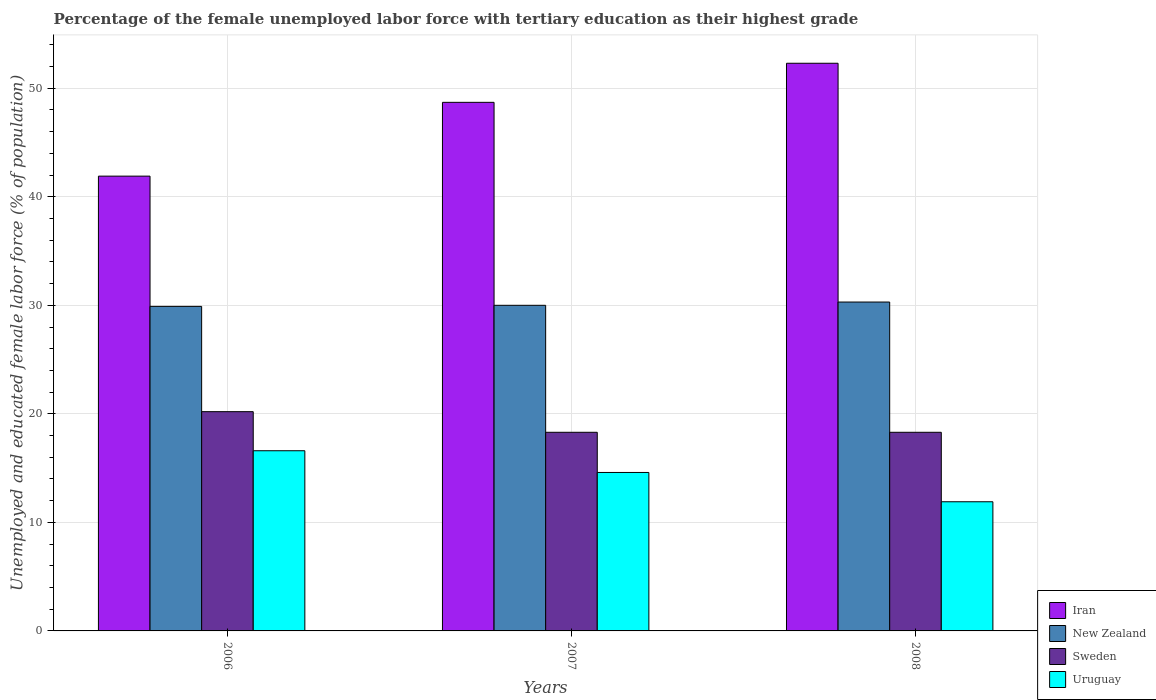How many different coloured bars are there?
Give a very brief answer. 4. How many bars are there on the 2nd tick from the right?
Ensure brevity in your answer.  4. What is the label of the 3rd group of bars from the left?
Your response must be concise. 2008. In how many cases, is the number of bars for a given year not equal to the number of legend labels?
Ensure brevity in your answer.  0. What is the percentage of the unemployed female labor force with tertiary education in New Zealand in 2008?
Give a very brief answer. 30.3. Across all years, what is the maximum percentage of the unemployed female labor force with tertiary education in Uruguay?
Keep it short and to the point. 16.6. Across all years, what is the minimum percentage of the unemployed female labor force with tertiary education in Iran?
Provide a succinct answer. 41.9. What is the total percentage of the unemployed female labor force with tertiary education in Uruguay in the graph?
Your answer should be very brief. 43.1. What is the difference between the percentage of the unemployed female labor force with tertiary education in Uruguay in 2007 and the percentage of the unemployed female labor force with tertiary education in Sweden in 2006?
Provide a succinct answer. -5.6. What is the average percentage of the unemployed female labor force with tertiary education in New Zealand per year?
Your response must be concise. 30.07. In the year 2008, what is the difference between the percentage of the unemployed female labor force with tertiary education in Sweden and percentage of the unemployed female labor force with tertiary education in Iran?
Your response must be concise. -34. In how many years, is the percentage of the unemployed female labor force with tertiary education in Uruguay greater than 52 %?
Keep it short and to the point. 0. What is the ratio of the percentage of the unemployed female labor force with tertiary education in Uruguay in 2006 to that in 2007?
Your answer should be compact. 1.14. Is the percentage of the unemployed female labor force with tertiary education in Sweden in 2006 less than that in 2007?
Give a very brief answer. No. What is the difference between the highest and the second highest percentage of the unemployed female labor force with tertiary education in New Zealand?
Offer a very short reply. 0.3. What is the difference between the highest and the lowest percentage of the unemployed female labor force with tertiary education in Iran?
Offer a very short reply. 10.4. Is the sum of the percentage of the unemployed female labor force with tertiary education in New Zealand in 2007 and 2008 greater than the maximum percentage of the unemployed female labor force with tertiary education in Sweden across all years?
Give a very brief answer. Yes. Is it the case that in every year, the sum of the percentage of the unemployed female labor force with tertiary education in Iran and percentage of the unemployed female labor force with tertiary education in Sweden is greater than the sum of percentage of the unemployed female labor force with tertiary education in Uruguay and percentage of the unemployed female labor force with tertiary education in New Zealand?
Give a very brief answer. No. What does the 1st bar from the left in 2006 represents?
Provide a short and direct response. Iran. What does the 3rd bar from the right in 2006 represents?
Give a very brief answer. New Zealand. Is it the case that in every year, the sum of the percentage of the unemployed female labor force with tertiary education in Sweden and percentage of the unemployed female labor force with tertiary education in Iran is greater than the percentage of the unemployed female labor force with tertiary education in Uruguay?
Your answer should be very brief. Yes. How many bars are there?
Your answer should be compact. 12. How many years are there in the graph?
Give a very brief answer. 3. What is the difference between two consecutive major ticks on the Y-axis?
Your response must be concise. 10. Where does the legend appear in the graph?
Offer a terse response. Bottom right. How many legend labels are there?
Offer a terse response. 4. How are the legend labels stacked?
Provide a short and direct response. Vertical. What is the title of the graph?
Your answer should be compact. Percentage of the female unemployed labor force with tertiary education as their highest grade. Does "Estonia" appear as one of the legend labels in the graph?
Offer a terse response. No. What is the label or title of the Y-axis?
Offer a very short reply. Unemployed and educated female labor force (% of population). What is the Unemployed and educated female labor force (% of population) of Iran in 2006?
Keep it short and to the point. 41.9. What is the Unemployed and educated female labor force (% of population) of New Zealand in 2006?
Your response must be concise. 29.9. What is the Unemployed and educated female labor force (% of population) in Sweden in 2006?
Your answer should be compact. 20.2. What is the Unemployed and educated female labor force (% of population) of Uruguay in 2006?
Make the answer very short. 16.6. What is the Unemployed and educated female labor force (% of population) in Iran in 2007?
Ensure brevity in your answer.  48.7. What is the Unemployed and educated female labor force (% of population) in New Zealand in 2007?
Make the answer very short. 30. What is the Unemployed and educated female labor force (% of population) of Sweden in 2007?
Keep it short and to the point. 18.3. What is the Unemployed and educated female labor force (% of population) of Uruguay in 2007?
Offer a very short reply. 14.6. What is the Unemployed and educated female labor force (% of population) in Iran in 2008?
Provide a short and direct response. 52.3. What is the Unemployed and educated female labor force (% of population) in New Zealand in 2008?
Make the answer very short. 30.3. What is the Unemployed and educated female labor force (% of population) of Sweden in 2008?
Offer a terse response. 18.3. What is the Unemployed and educated female labor force (% of population) of Uruguay in 2008?
Ensure brevity in your answer.  11.9. Across all years, what is the maximum Unemployed and educated female labor force (% of population) of Iran?
Offer a terse response. 52.3. Across all years, what is the maximum Unemployed and educated female labor force (% of population) in New Zealand?
Offer a terse response. 30.3. Across all years, what is the maximum Unemployed and educated female labor force (% of population) in Sweden?
Provide a succinct answer. 20.2. Across all years, what is the maximum Unemployed and educated female labor force (% of population) in Uruguay?
Keep it short and to the point. 16.6. Across all years, what is the minimum Unemployed and educated female labor force (% of population) in Iran?
Ensure brevity in your answer.  41.9. Across all years, what is the minimum Unemployed and educated female labor force (% of population) of New Zealand?
Provide a short and direct response. 29.9. Across all years, what is the minimum Unemployed and educated female labor force (% of population) of Sweden?
Give a very brief answer. 18.3. Across all years, what is the minimum Unemployed and educated female labor force (% of population) in Uruguay?
Your response must be concise. 11.9. What is the total Unemployed and educated female labor force (% of population) in Iran in the graph?
Provide a short and direct response. 142.9. What is the total Unemployed and educated female labor force (% of population) in New Zealand in the graph?
Make the answer very short. 90.2. What is the total Unemployed and educated female labor force (% of population) in Sweden in the graph?
Your answer should be compact. 56.8. What is the total Unemployed and educated female labor force (% of population) in Uruguay in the graph?
Offer a very short reply. 43.1. What is the difference between the Unemployed and educated female labor force (% of population) of Iran in 2006 and that in 2007?
Ensure brevity in your answer.  -6.8. What is the difference between the Unemployed and educated female labor force (% of population) in New Zealand in 2006 and that in 2007?
Your answer should be very brief. -0.1. What is the difference between the Unemployed and educated female labor force (% of population) in Uruguay in 2006 and that in 2007?
Offer a terse response. 2. What is the difference between the Unemployed and educated female labor force (% of population) in Iran in 2006 and that in 2008?
Offer a terse response. -10.4. What is the difference between the Unemployed and educated female labor force (% of population) of Sweden in 2006 and that in 2008?
Provide a short and direct response. 1.9. What is the difference between the Unemployed and educated female labor force (% of population) in Uruguay in 2006 and that in 2008?
Offer a very short reply. 4.7. What is the difference between the Unemployed and educated female labor force (% of population) of Uruguay in 2007 and that in 2008?
Keep it short and to the point. 2.7. What is the difference between the Unemployed and educated female labor force (% of population) in Iran in 2006 and the Unemployed and educated female labor force (% of population) in Sweden in 2007?
Your response must be concise. 23.6. What is the difference between the Unemployed and educated female labor force (% of population) in Iran in 2006 and the Unemployed and educated female labor force (% of population) in Uruguay in 2007?
Your answer should be very brief. 27.3. What is the difference between the Unemployed and educated female labor force (% of population) of New Zealand in 2006 and the Unemployed and educated female labor force (% of population) of Sweden in 2007?
Offer a terse response. 11.6. What is the difference between the Unemployed and educated female labor force (% of population) of Sweden in 2006 and the Unemployed and educated female labor force (% of population) of Uruguay in 2007?
Your answer should be very brief. 5.6. What is the difference between the Unemployed and educated female labor force (% of population) in Iran in 2006 and the Unemployed and educated female labor force (% of population) in Sweden in 2008?
Provide a succinct answer. 23.6. What is the difference between the Unemployed and educated female labor force (% of population) in Iran in 2006 and the Unemployed and educated female labor force (% of population) in Uruguay in 2008?
Make the answer very short. 30. What is the difference between the Unemployed and educated female labor force (% of population) of New Zealand in 2006 and the Unemployed and educated female labor force (% of population) of Sweden in 2008?
Your response must be concise. 11.6. What is the difference between the Unemployed and educated female labor force (% of population) of New Zealand in 2006 and the Unemployed and educated female labor force (% of population) of Uruguay in 2008?
Ensure brevity in your answer.  18. What is the difference between the Unemployed and educated female labor force (% of population) in Iran in 2007 and the Unemployed and educated female labor force (% of population) in Sweden in 2008?
Make the answer very short. 30.4. What is the difference between the Unemployed and educated female labor force (% of population) of Iran in 2007 and the Unemployed and educated female labor force (% of population) of Uruguay in 2008?
Offer a very short reply. 36.8. What is the difference between the Unemployed and educated female labor force (% of population) in New Zealand in 2007 and the Unemployed and educated female labor force (% of population) in Uruguay in 2008?
Ensure brevity in your answer.  18.1. What is the average Unemployed and educated female labor force (% of population) of Iran per year?
Offer a very short reply. 47.63. What is the average Unemployed and educated female labor force (% of population) of New Zealand per year?
Provide a succinct answer. 30.07. What is the average Unemployed and educated female labor force (% of population) in Sweden per year?
Your answer should be compact. 18.93. What is the average Unemployed and educated female labor force (% of population) in Uruguay per year?
Keep it short and to the point. 14.37. In the year 2006, what is the difference between the Unemployed and educated female labor force (% of population) in Iran and Unemployed and educated female labor force (% of population) in Sweden?
Your answer should be compact. 21.7. In the year 2006, what is the difference between the Unemployed and educated female labor force (% of population) of Iran and Unemployed and educated female labor force (% of population) of Uruguay?
Provide a succinct answer. 25.3. In the year 2006, what is the difference between the Unemployed and educated female labor force (% of population) of New Zealand and Unemployed and educated female labor force (% of population) of Uruguay?
Keep it short and to the point. 13.3. In the year 2006, what is the difference between the Unemployed and educated female labor force (% of population) in Sweden and Unemployed and educated female labor force (% of population) in Uruguay?
Make the answer very short. 3.6. In the year 2007, what is the difference between the Unemployed and educated female labor force (% of population) of Iran and Unemployed and educated female labor force (% of population) of New Zealand?
Your answer should be compact. 18.7. In the year 2007, what is the difference between the Unemployed and educated female labor force (% of population) in Iran and Unemployed and educated female labor force (% of population) in Sweden?
Offer a very short reply. 30.4. In the year 2007, what is the difference between the Unemployed and educated female labor force (% of population) in Iran and Unemployed and educated female labor force (% of population) in Uruguay?
Offer a very short reply. 34.1. In the year 2007, what is the difference between the Unemployed and educated female labor force (% of population) of New Zealand and Unemployed and educated female labor force (% of population) of Uruguay?
Your answer should be compact. 15.4. In the year 2007, what is the difference between the Unemployed and educated female labor force (% of population) in Sweden and Unemployed and educated female labor force (% of population) in Uruguay?
Your response must be concise. 3.7. In the year 2008, what is the difference between the Unemployed and educated female labor force (% of population) in Iran and Unemployed and educated female labor force (% of population) in New Zealand?
Offer a very short reply. 22. In the year 2008, what is the difference between the Unemployed and educated female labor force (% of population) in Iran and Unemployed and educated female labor force (% of population) in Sweden?
Offer a terse response. 34. In the year 2008, what is the difference between the Unemployed and educated female labor force (% of population) of Iran and Unemployed and educated female labor force (% of population) of Uruguay?
Make the answer very short. 40.4. In the year 2008, what is the difference between the Unemployed and educated female labor force (% of population) of New Zealand and Unemployed and educated female labor force (% of population) of Sweden?
Your answer should be very brief. 12. What is the ratio of the Unemployed and educated female labor force (% of population) in Iran in 2006 to that in 2007?
Your answer should be compact. 0.86. What is the ratio of the Unemployed and educated female labor force (% of population) in New Zealand in 2006 to that in 2007?
Your response must be concise. 1. What is the ratio of the Unemployed and educated female labor force (% of population) of Sweden in 2006 to that in 2007?
Provide a short and direct response. 1.1. What is the ratio of the Unemployed and educated female labor force (% of population) in Uruguay in 2006 to that in 2007?
Offer a terse response. 1.14. What is the ratio of the Unemployed and educated female labor force (% of population) in Iran in 2006 to that in 2008?
Ensure brevity in your answer.  0.8. What is the ratio of the Unemployed and educated female labor force (% of population) of New Zealand in 2006 to that in 2008?
Keep it short and to the point. 0.99. What is the ratio of the Unemployed and educated female labor force (% of population) in Sweden in 2006 to that in 2008?
Your answer should be compact. 1.1. What is the ratio of the Unemployed and educated female labor force (% of population) in Uruguay in 2006 to that in 2008?
Provide a succinct answer. 1.4. What is the ratio of the Unemployed and educated female labor force (% of population) in Iran in 2007 to that in 2008?
Ensure brevity in your answer.  0.93. What is the ratio of the Unemployed and educated female labor force (% of population) of Uruguay in 2007 to that in 2008?
Offer a terse response. 1.23. What is the difference between the highest and the second highest Unemployed and educated female labor force (% of population) of New Zealand?
Keep it short and to the point. 0.3. What is the difference between the highest and the second highest Unemployed and educated female labor force (% of population) in Uruguay?
Provide a short and direct response. 2. What is the difference between the highest and the lowest Unemployed and educated female labor force (% of population) in Iran?
Give a very brief answer. 10.4. What is the difference between the highest and the lowest Unemployed and educated female labor force (% of population) of Uruguay?
Offer a very short reply. 4.7. 